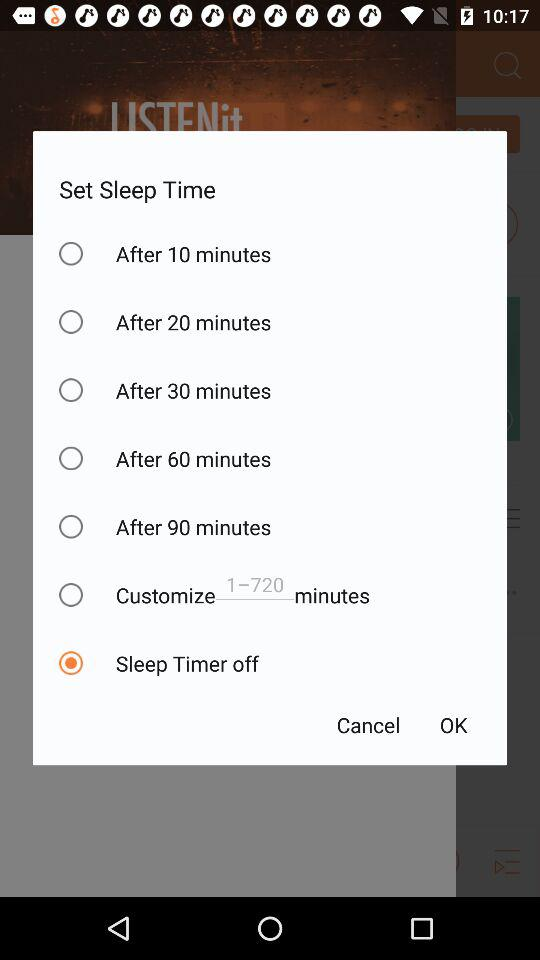How many minutes longer is the sleep timer for 60 minutes than for 30 minutes?
Answer the question using a single word or phrase. 30 